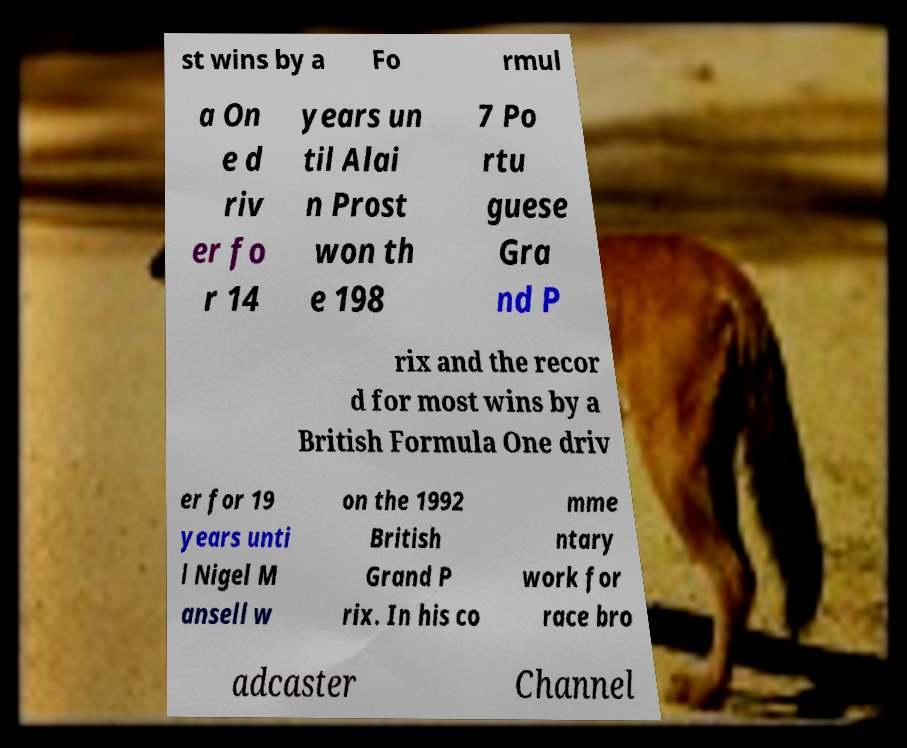Can you accurately transcribe the text from the provided image for me? st wins by a Fo rmul a On e d riv er fo r 14 years un til Alai n Prost won th e 198 7 Po rtu guese Gra nd P rix and the recor d for most wins by a British Formula One driv er for 19 years unti l Nigel M ansell w on the 1992 British Grand P rix. In his co mme ntary work for race bro adcaster Channel 